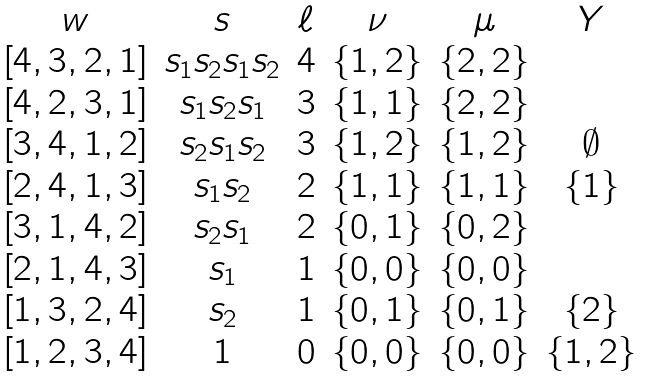Convert formula to latex. <formula><loc_0><loc_0><loc_500><loc_500>\begin{matrix} & & w & s & \ell & \nu & \mu & Y \\ & & [ 4 , 3 , 2 , 1 ] & s _ { 1 } s _ { 2 } s _ { 1 } s _ { 2 } & 4 & \{ 1 , 2 \} & \{ 2 , 2 \} \\ & & [ 4 , 2 , 3 , 1 ] & s _ { 1 } s _ { 2 } s _ { 1 } & 3 & \{ 1 , 1 \} & \{ 2 , 2 \} \\ & & [ 3 , 4 , 1 , 2 ] & s _ { 2 } s _ { 1 } s _ { 2 } & 3 & \{ 1 , 2 \} & \{ 1 , 2 \} & \emptyset \\ & & [ 2 , 4 , 1 , 3 ] & s _ { 1 } s _ { 2 } & 2 & \{ 1 , 1 \} & \{ 1 , 1 \} & \{ 1 \} \\ & & [ 3 , 1 , 4 , 2 ] & s _ { 2 } s _ { 1 } & 2 & \{ 0 , 1 \} & \{ 0 , 2 \} \\ & & [ 2 , 1 , 4 , 3 ] & s _ { 1 } & 1 & \{ 0 , 0 \} & \{ 0 , 0 \} \\ & & [ 1 , 3 , 2 , 4 ] & s _ { 2 } & 1 & \{ 0 , 1 \} & \{ 0 , 1 \} & \{ 2 \} \\ & & [ 1 , 2 , 3 , 4 ] & 1 & 0 & \{ 0 , 0 \} & \{ 0 , 0 \} & \{ 1 , 2 \} \\ \end{matrix}</formula> 